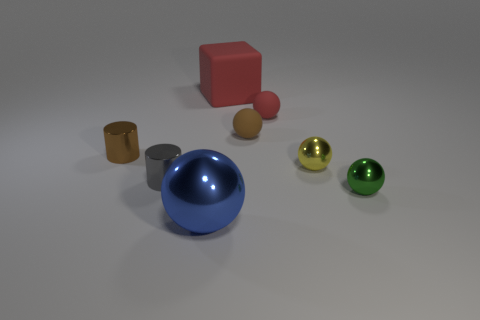Subtract 2 spheres. How many spheres are left? 3 Add 1 red metal objects. How many objects exist? 9 Subtract all blocks. How many objects are left? 7 Subtract all tiny yellow matte spheres. Subtract all brown metallic cylinders. How many objects are left? 7 Add 7 large red matte cubes. How many large red matte cubes are left? 8 Add 7 tiny brown things. How many tiny brown things exist? 9 Subtract 1 brown cylinders. How many objects are left? 7 